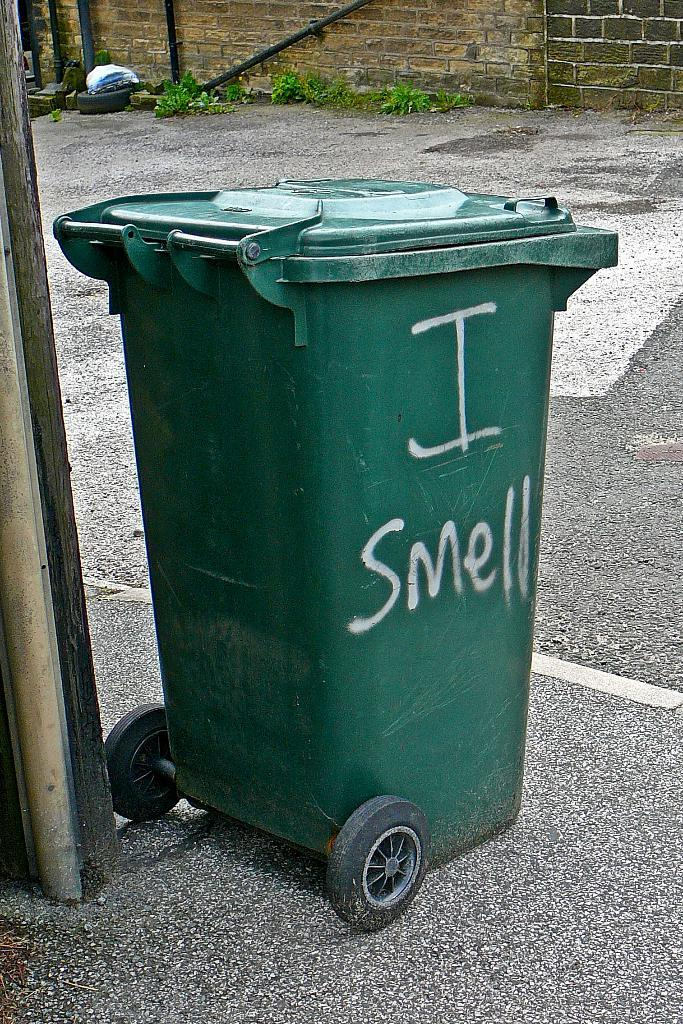<image>
Share a concise interpretation of the image provided. Someone has painted "I smell" on the side of a trash bin. 